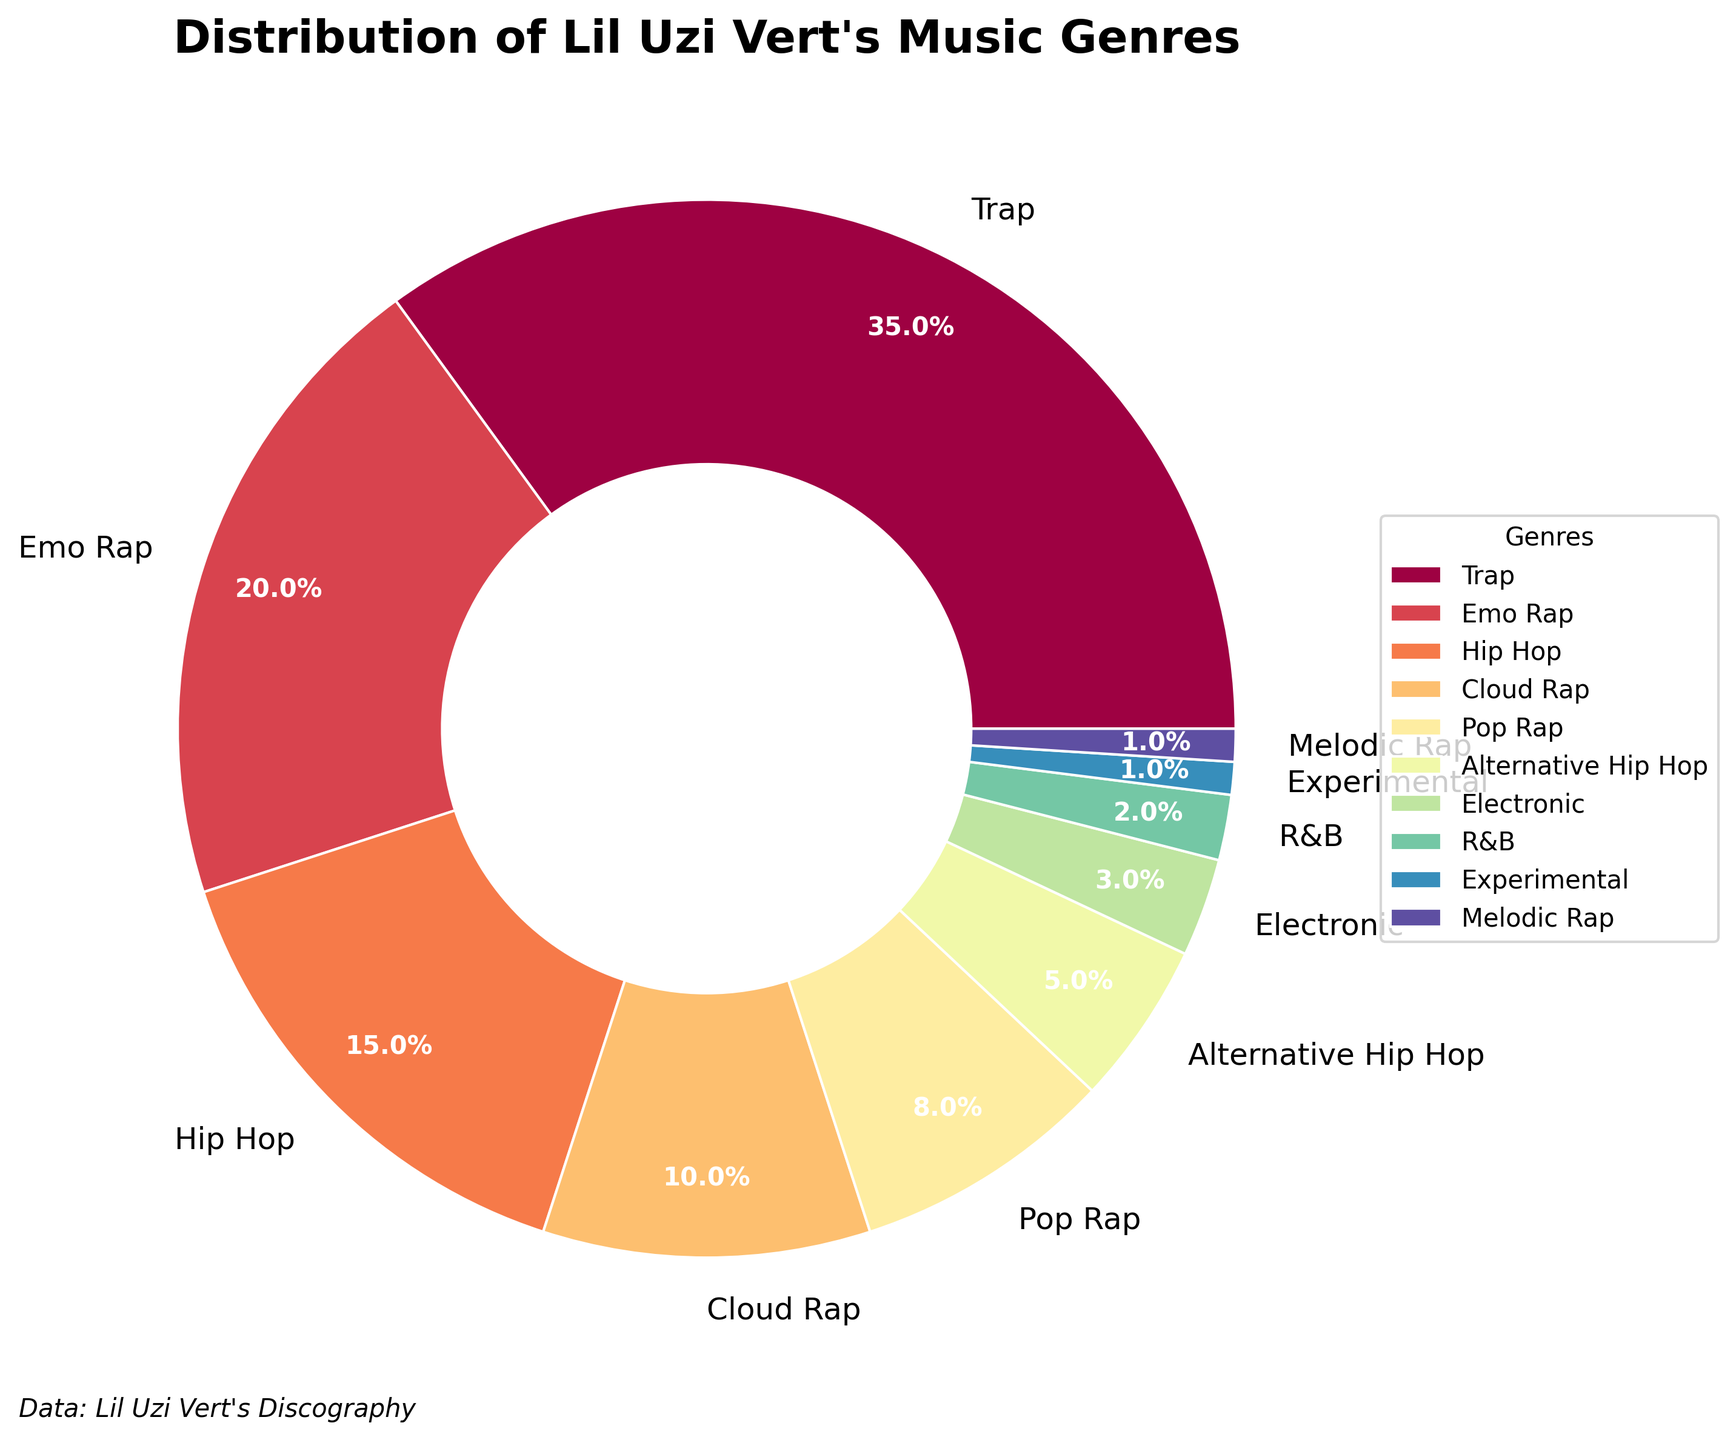What's the most common genre in Lil Uzi Vert's music? The pie chart shows the distribution of different genres in Lil Uzi Vert's discography. The 'Trap' genre occupies the largest segment of the pie chart.
Answer: Trap Which genres together make up more than half of Lil Uzi Vert's discography? To find this, we can add up the percentages of the largest genres until we exceed 50%. 'Trap' is 35%, 'Emo Rap' is 20%. Adding these, we get 55%.
Answer: Trap, Emo Rap Is 'Cloud Rap' more prevalent than 'Pop Rap' in Lil Uzi Vert's music? Check the pie chart segments labeled 'Cloud Rap' and 'Pop Rap'. 'Cloud Rap' is 10%, whereas 'Pop Rap' is 8%. Since 10% is greater than 8%, 'Cloud Rap' is more prevalent.
Answer: Yes How much percentage does 'Hip Hop' and 'Alternative Hip Hop' together contribute to Lil Uzi Vert's discography? Sum the percentages of 'Hip Hop' (15%) and 'Alternative Hip Hop' (5%). 15% + 5% = 20%.
Answer: 20% Which genre contributes the least to Lil Uzi Vert's discography? Identify the smallest segment in the pie chart. 'Experimental' and 'Melodic Rap' both have the smallest segments, each contributing 1%.
Answer: Experimental, Melodic Rap Is the combined percentage of 'Electronic' and 'R&B' equal to or greater than 'Hip Hop'? 'Electronic' is 3% and 'R&B' is 2%, so their combined percentage is 3% + 2% = 5%. 'Hip Hop' has 15%, so the combined percentage of 'Electronic' and 'R&B' (5%) is less.
Answer: No Which genre has a larger percentage: 'Alternative Hip Hop' or 'Hip Hop'? Look at the pie chart and compare the segments for 'Alternative Hip Hop' and 'Hip Hop'. 'Hip Hop' is 15%, 'Alternative Hip Hop' is 5%. 15% is greater than 5%.
Answer: Hip Hop What percentage of Lil Uzi Vert's discography does 'Pop Rap' and 'Alternative Hip Hop' together cover? Add the percentages for 'Pop Rap' (8%) and 'Alternative Hip Hop' (5%). 8% + 5% = 13%.
Answer: 13% How many genres in Lil Uzi Vert's discography have a percentage less than or equal to 5%? Identify the segments with 5% or less. They are 'Alternative Hip Hop' (5%), 'Electronic' (3%), 'R&B' (2%), 'Experimental' (1%), and 'Melodic Rap' (1%). That’s 5 genres.
Answer: 5 